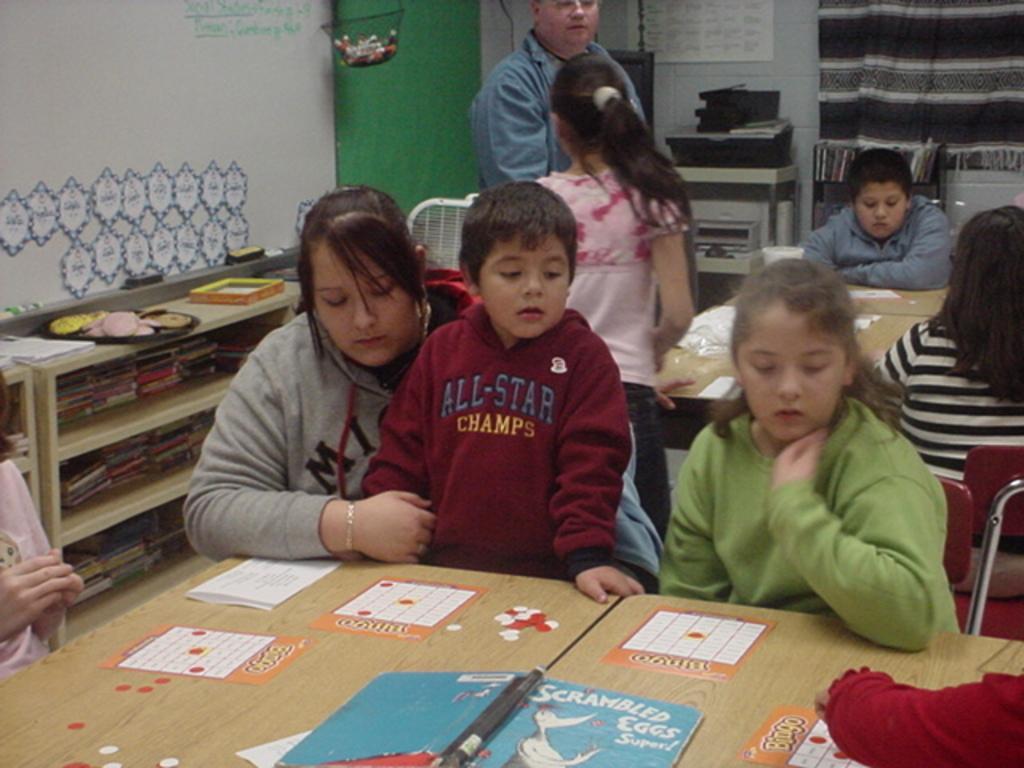How would you summarize this image in a sentence or two? In this image I can see a group of people, chairs, tables and shelf on the floor. In the background I can see a wall, curtain, board and so on. This image is taken may be in a hall. 